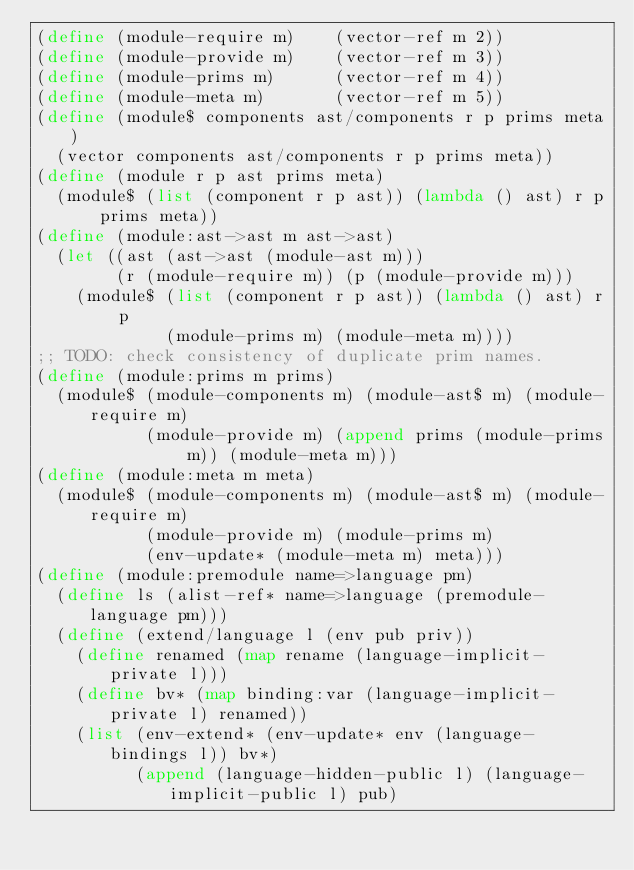<code> <loc_0><loc_0><loc_500><loc_500><_Scheme_>(define (module-require m)    (vector-ref m 2))
(define (module-provide m)    (vector-ref m 3))
(define (module-prims m)      (vector-ref m 4))
(define (module-meta m)       (vector-ref m 5))
(define (module$ components ast/components r p prims meta)
  (vector components ast/components r p prims meta))
(define (module r p ast prims meta)
  (module$ (list (component r p ast)) (lambda () ast) r p prims meta))
(define (module:ast->ast m ast->ast)
  (let ((ast (ast->ast (module-ast m)))
        (r (module-require m)) (p (module-provide m)))
    (module$ (list (component r p ast)) (lambda () ast) r p
             (module-prims m) (module-meta m))))
;; TODO: check consistency of duplicate prim names.
(define (module:prims m prims)
  (module$ (module-components m) (module-ast$ m) (module-require m)
           (module-provide m) (append prims (module-prims m)) (module-meta m)))
(define (module:meta m meta)
  (module$ (module-components m) (module-ast$ m) (module-require m)
           (module-provide m) (module-prims m)
           (env-update* (module-meta m) meta)))
(define (module:premodule name=>language pm)
  (define ls (alist-ref* name=>language (premodule-language pm)))
  (define (extend/language l (env pub priv))
    (define renamed (map rename (language-implicit-private l)))
    (define bv* (map binding:var (language-implicit-private l) renamed))
    (list (env-extend* (env-update* env (language-bindings l)) bv*)
          (append (language-hidden-public l) (language-implicit-public l) pub)</code> 